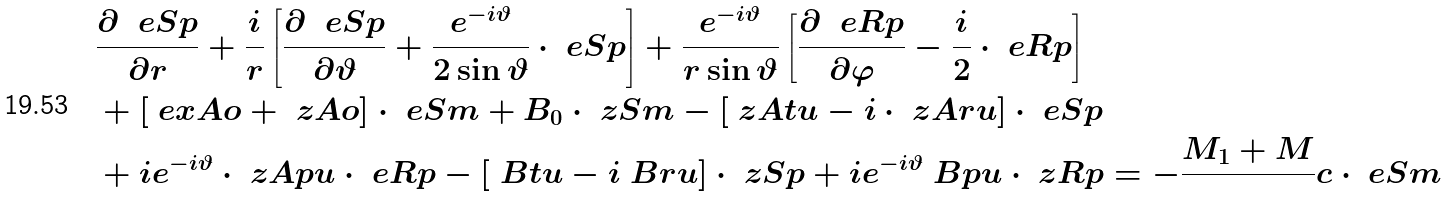Convert formula to latex. <formula><loc_0><loc_0><loc_500><loc_500>& \frac { \partial \ \ e S p } { \partial r } + \frac { i } { r } \left [ \frac { \partial \ \ e S p } { \partial \vartheta } + \frac { e ^ { - i \vartheta } } { 2 \sin \vartheta } \cdot \ e S p \right ] + \frac { e ^ { - i \vartheta } } { r \sin \vartheta } \left [ \frac { \partial \ \ e R p } { \partial \varphi } - \frac { i } { 2 } \cdot \ e R p \right ] \\ & + [ \ e x A o + \ z A o ] \cdot \ e S m + B _ { 0 } \cdot \ z S m - [ \ z A t u - i \cdot \ z A r u ] \cdot \ e S p \\ & + i e ^ { - i \vartheta } \cdot \ z A p u \cdot \ e R p - [ \ B t u - i \ B r u ] \cdot \ z S p + i e ^ { - i \vartheta } \ B p u \cdot \ z R p = - \frac { M _ { 1 } + M } { } c \cdot \ e S m \\</formula> 